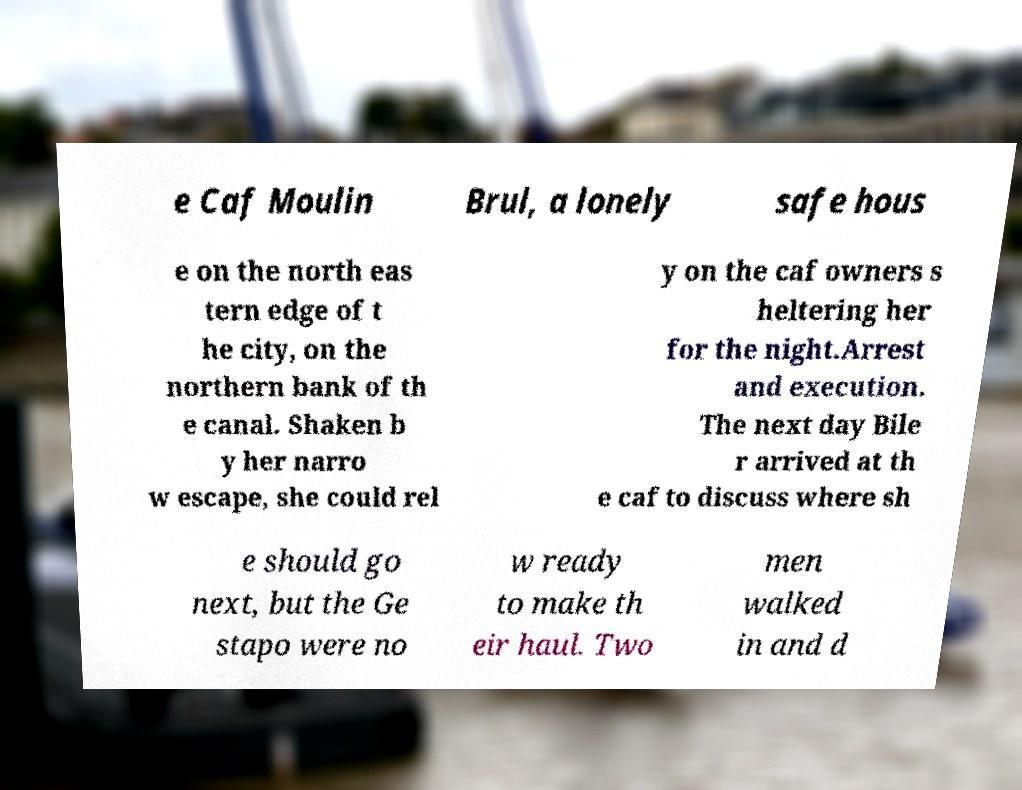Can you accurately transcribe the text from the provided image for me? e Caf Moulin Brul, a lonely safe hous e on the north eas tern edge of t he city, on the northern bank of th e canal. Shaken b y her narro w escape, she could rel y on the caf owners s heltering her for the night.Arrest and execution. The next day Bile r arrived at th e caf to discuss where sh e should go next, but the Ge stapo were no w ready to make th eir haul. Two men walked in and d 